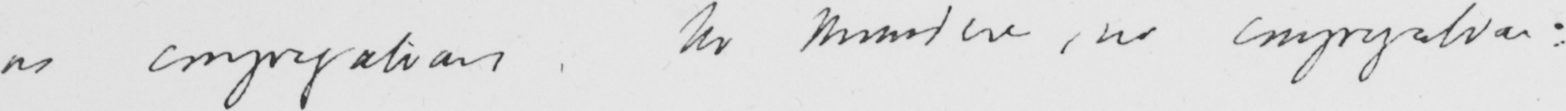Can you read and transcribe this handwriting? as congregations . No Minister , no congregation : 